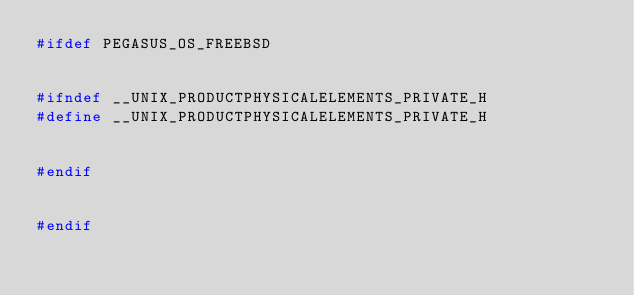Convert code to text. <code><loc_0><loc_0><loc_500><loc_500><_C++_>#ifdef PEGASUS_OS_FREEBSD


#ifndef __UNIX_PRODUCTPHYSICALELEMENTS_PRIVATE_H
#define __UNIX_PRODUCTPHYSICALELEMENTS_PRIVATE_H


#endif


#endif
</code> 